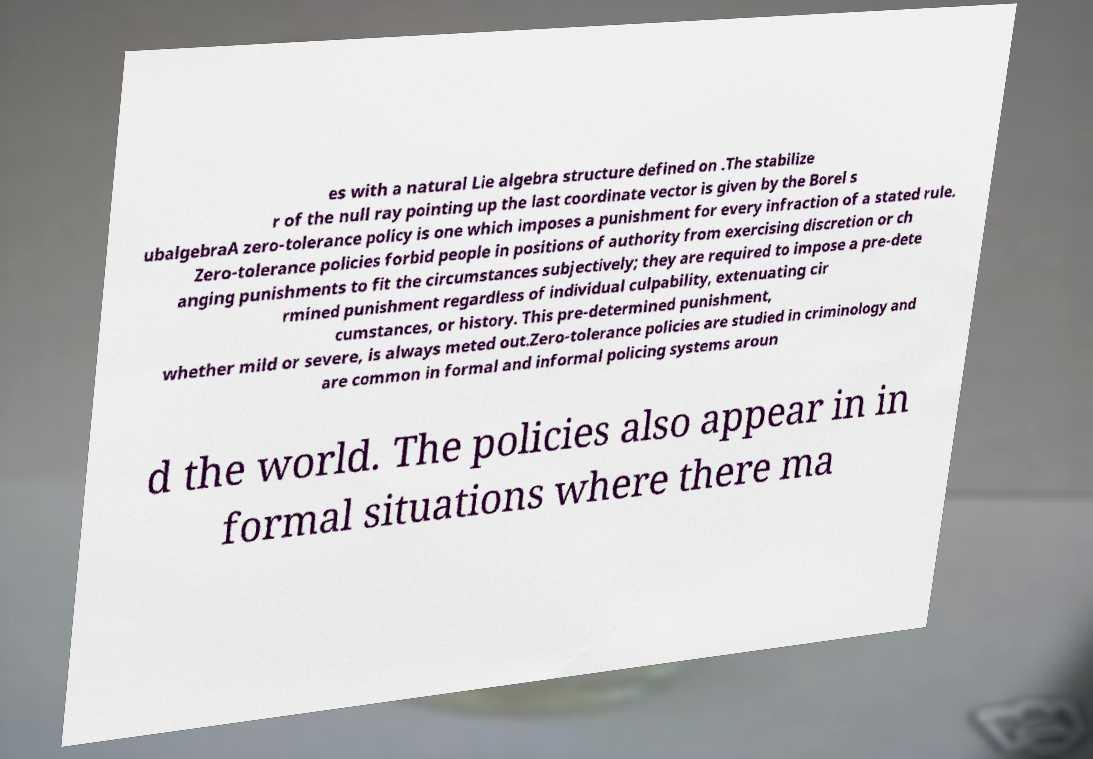Could you assist in decoding the text presented in this image and type it out clearly? es with a natural Lie algebra structure defined on .The stabilize r of the null ray pointing up the last coordinate vector is given by the Borel s ubalgebraA zero-tolerance policy is one which imposes a punishment for every infraction of a stated rule. Zero-tolerance policies forbid people in positions of authority from exercising discretion or ch anging punishments to fit the circumstances subjectively; they are required to impose a pre-dete rmined punishment regardless of individual culpability, extenuating cir cumstances, or history. This pre-determined punishment, whether mild or severe, is always meted out.Zero-tolerance policies are studied in criminology and are common in formal and informal policing systems aroun d the world. The policies also appear in in formal situations where there ma 